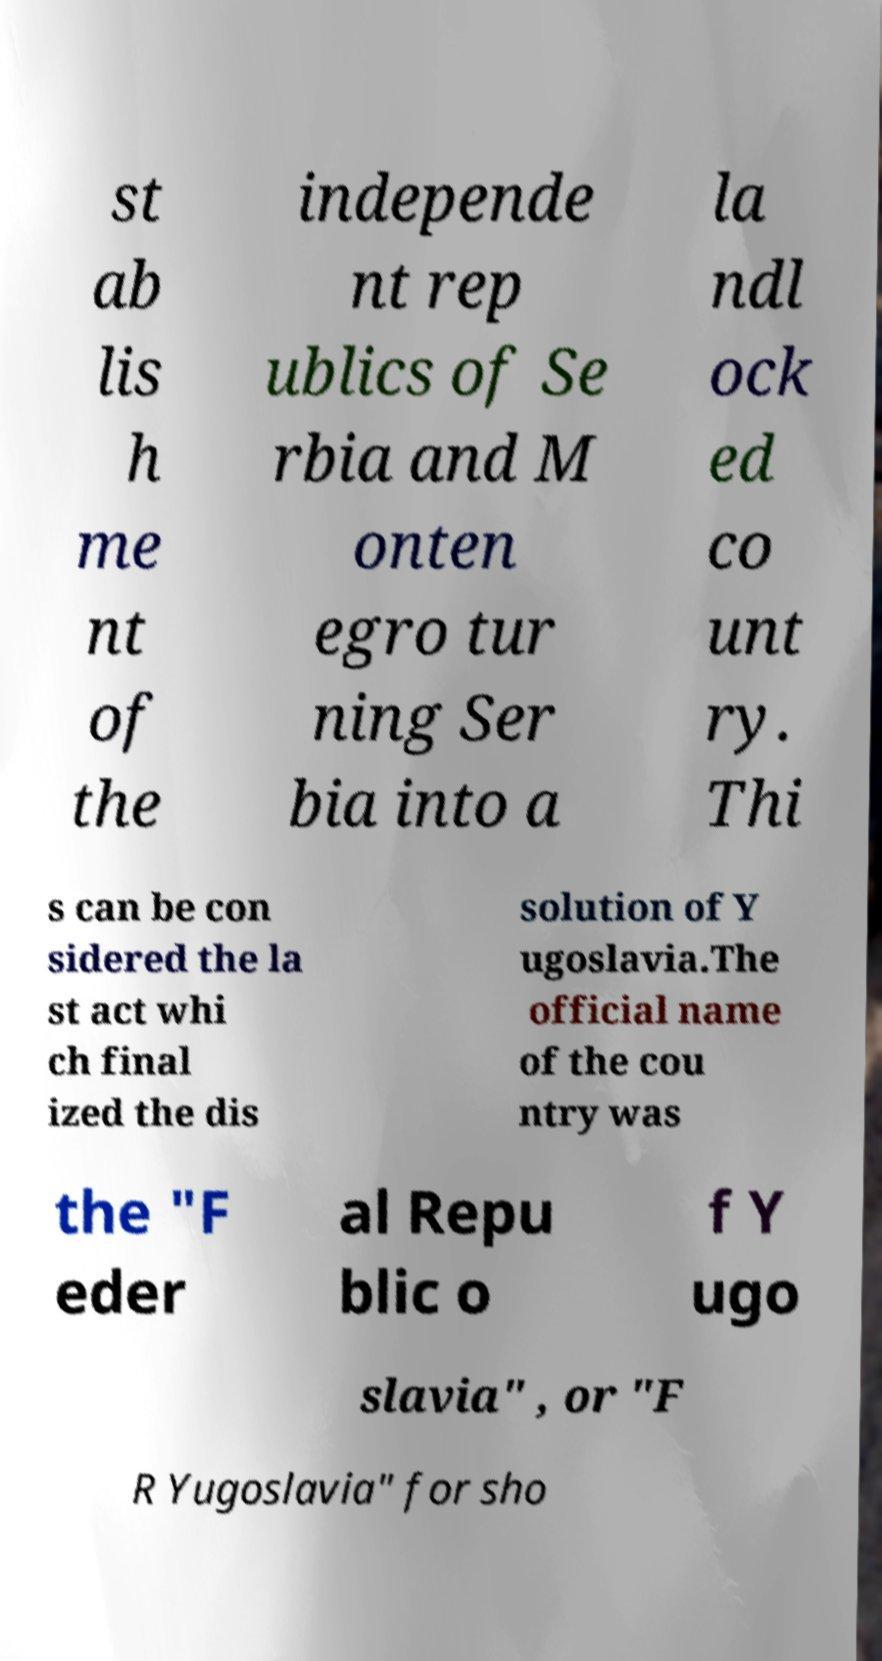What messages or text are displayed in this image? I need them in a readable, typed format. st ab lis h me nt of the independe nt rep ublics of Se rbia and M onten egro tur ning Ser bia into a la ndl ock ed co unt ry. Thi s can be con sidered the la st act whi ch final ized the dis solution of Y ugoslavia.The official name of the cou ntry was the "F eder al Repu blic o f Y ugo slavia" , or "F R Yugoslavia" for sho 